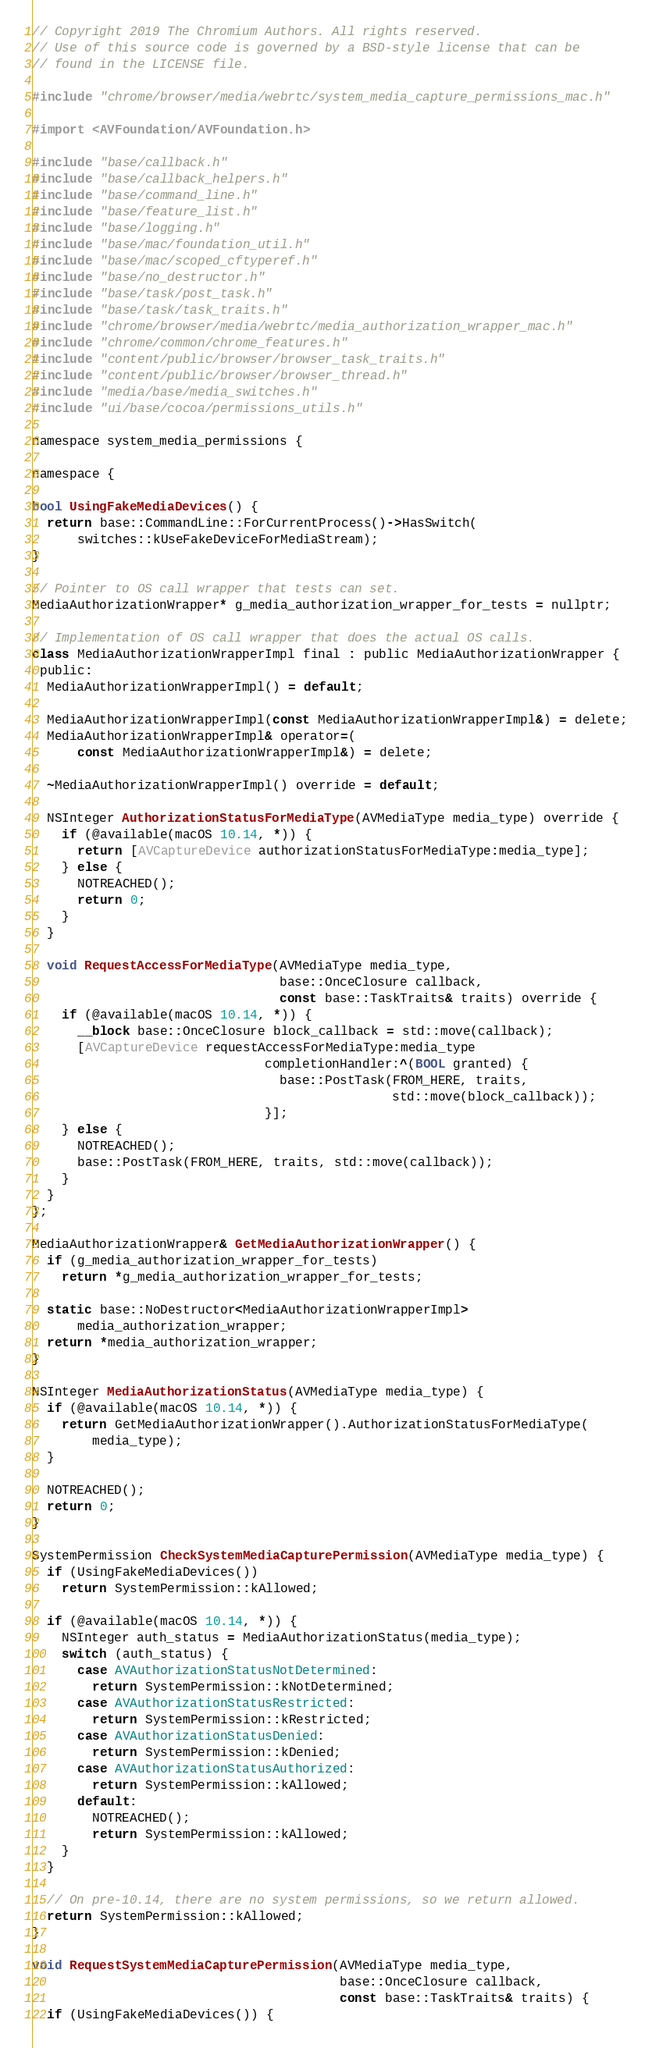<code> <loc_0><loc_0><loc_500><loc_500><_ObjectiveC_>// Copyright 2019 The Chromium Authors. All rights reserved.
// Use of this source code is governed by a BSD-style license that can be
// found in the LICENSE file.

#include "chrome/browser/media/webrtc/system_media_capture_permissions_mac.h"

#import <AVFoundation/AVFoundation.h>

#include "base/callback.h"
#include "base/callback_helpers.h"
#include "base/command_line.h"
#include "base/feature_list.h"
#include "base/logging.h"
#include "base/mac/foundation_util.h"
#include "base/mac/scoped_cftyperef.h"
#include "base/no_destructor.h"
#include "base/task/post_task.h"
#include "base/task/task_traits.h"
#include "chrome/browser/media/webrtc/media_authorization_wrapper_mac.h"
#include "chrome/common/chrome_features.h"
#include "content/public/browser/browser_task_traits.h"
#include "content/public/browser/browser_thread.h"
#include "media/base/media_switches.h"
#include "ui/base/cocoa/permissions_utils.h"

namespace system_media_permissions {

namespace {

bool UsingFakeMediaDevices() {
  return base::CommandLine::ForCurrentProcess()->HasSwitch(
      switches::kUseFakeDeviceForMediaStream);
}

// Pointer to OS call wrapper that tests can set.
MediaAuthorizationWrapper* g_media_authorization_wrapper_for_tests = nullptr;

// Implementation of OS call wrapper that does the actual OS calls.
class MediaAuthorizationWrapperImpl final : public MediaAuthorizationWrapper {
 public:
  MediaAuthorizationWrapperImpl() = default;

  MediaAuthorizationWrapperImpl(const MediaAuthorizationWrapperImpl&) = delete;
  MediaAuthorizationWrapperImpl& operator=(
      const MediaAuthorizationWrapperImpl&) = delete;

  ~MediaAuthorizationWrapperImpl() override = default;

  NSInteger AuthorizationStatusForMediaType(AVMediaType media_type) override {
    if (@available(macOS 10.14, *)) {
      return [AVCaptureDevice authorizationStatusForMediaType:media_type];
    } else {
      NOTREACHED();
      return 0;
    }
  }

  void RequestAccessForMediaType(AVMediaType media_type,
                                 base::OnceClosure callback,
                                 const base::TaskTraits& traits) override {
    if (@available(macOS 10.14, *)) {
      __block base::OnceClosure block_callback = std::move(callback);
      [AVCaptureDevice requestAccessForMediaType:media_type
                               completionHandler:^(BOOL granted) {
                                 base::PostTask(FROM_HERE, traits,
                                                std::move(block_callback));
                               }];
    } else {
      NOTREACHED();
      base::PostTask(FROM_HERE, traits, std::move(callback));
    }
  }
};

MediaAuthorizationWrapper& GetMediaAuthorizationWrapper() {
  if (g_media_authorization_wrapper_for_tests)
    return *g_media_authorization_wrapper_for_tests;

  static base::NoDestructor<MediaAuthorizationWrapperImpl>
      media_authorization_wrapper;
  return *media_authorization_wrapper;
}

NSInteger MediaAuthorizationStatus(AVMediaType media_type) {
  if (@available(macOS 10.14, *)) {
    return GetMediaAuthorizationWrapper().AuthorizationStatusForMediaType(
        media_type);
  }

  NOTREACHED();
  return 0;
}

SystemPermission CheckSystemMediaCapturePermission(AVMediaType media_type) {
  if (UsingFakeMediaDevices())
    return SystemPermission::kAllowed;

  if (@available(macOS 10.14, *)) {
    NSInteger auth_status = MediaAuthorizationStatus(media_type);
    switch (auth_status) {
      case AVAuthorizationStatusNotDetermined:
        return SystemPermission::kNotDetermined;
      case AVAuthorizationStatusRestricted:
        return SystemPermission::kRestricted;
      case AVAuthorizationStatusDenied:
        return SystemPermission::kDenied;
      case AVAuthorizationStatusAuthorized:
        return SystemPermission::kAllowed;
      default:
        NOTREACHED();
        return SystemPermission::kAllowed;
    }
  }

  // On pre-10.14, there are no system permissions, so we return allowed.
  return SystemPermission::kAllowed;
}

void RequestSystemMediaCapturePermission(AVMediaType media_type,
                                         base::OnceClosure callback,
                                         const base::TaskTraits& traits) {
  if (UsingFakeMediaDevices()) {</code> 